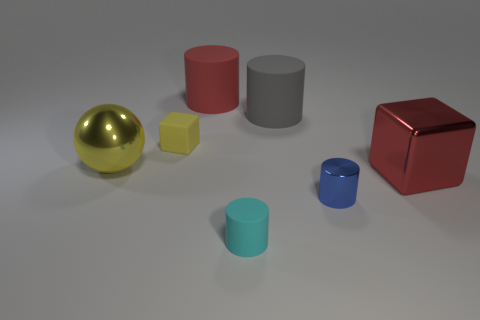Is there any other thing that has the same shape as the large yellow shiny thing?
Give a very brief answer. No. There is a cylinder left of the tiny cyan cylinder; does it have the same color as the large block?
Provide a short and direct response. Yes. How many balls are the same material as the big red block?
Give a very brief answer. 1. Is there a big red rubber thing left of the rubber cylinder in front of the large metal thing in front of the big yellow metal sphere?
Offer a terse response. Yes. What is the shape of the tiny metallic object?
Give a very brief answer. Cylinder. Is the red thing that is in front of the big yellow shiny ball made of the same material as the yellow object in front of the tiny yellow thing?
Keep it short and to the point. Yes. What number of tiny shiny cylinders are the same color as the big block?
Offer a terse response. 0. What is the shape of the metal thing that is in front of the metal sphere and behind the blue metal thing?
Keep it short and to the point. Cube. There is a matte cylinder that is on the right side of the large red matte cylinder and behind the tiny cyan object; what color is it?
Provide a succinct answer. Gray. Is the number of large red things that are on the left side of the small shiny cylinder greater than the number of yellow rubber blocks in front of the big metallic block?
Your answer should be compact. Yes. 